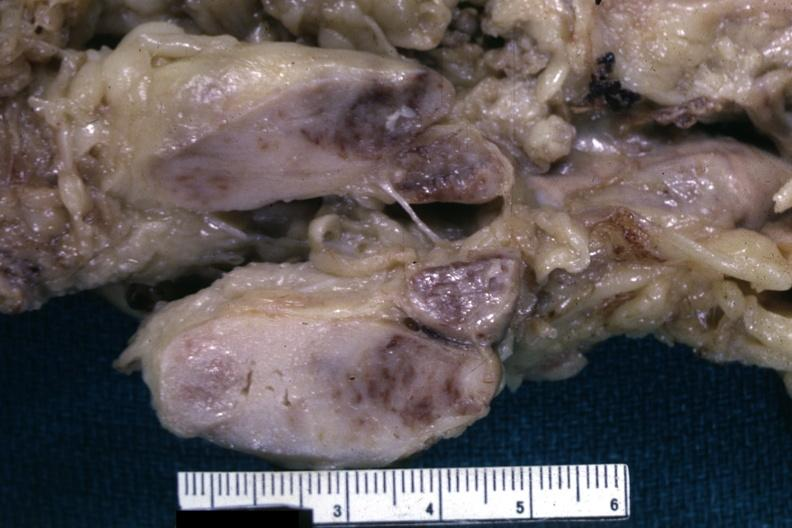what is present?
Answer the question using a single word or phrase. Malignant lymphoma 